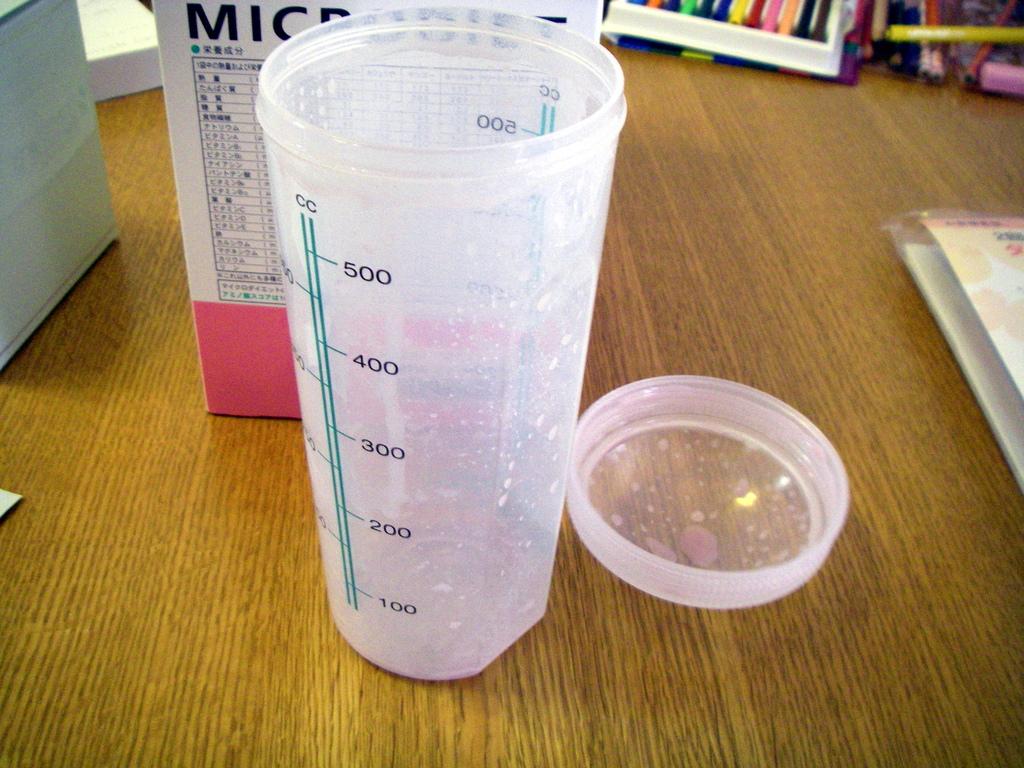What number is the glass filled up to?
Ensure brevity in your answer.  500. What is the measurement type?
Give a very brief answer. Cc. 